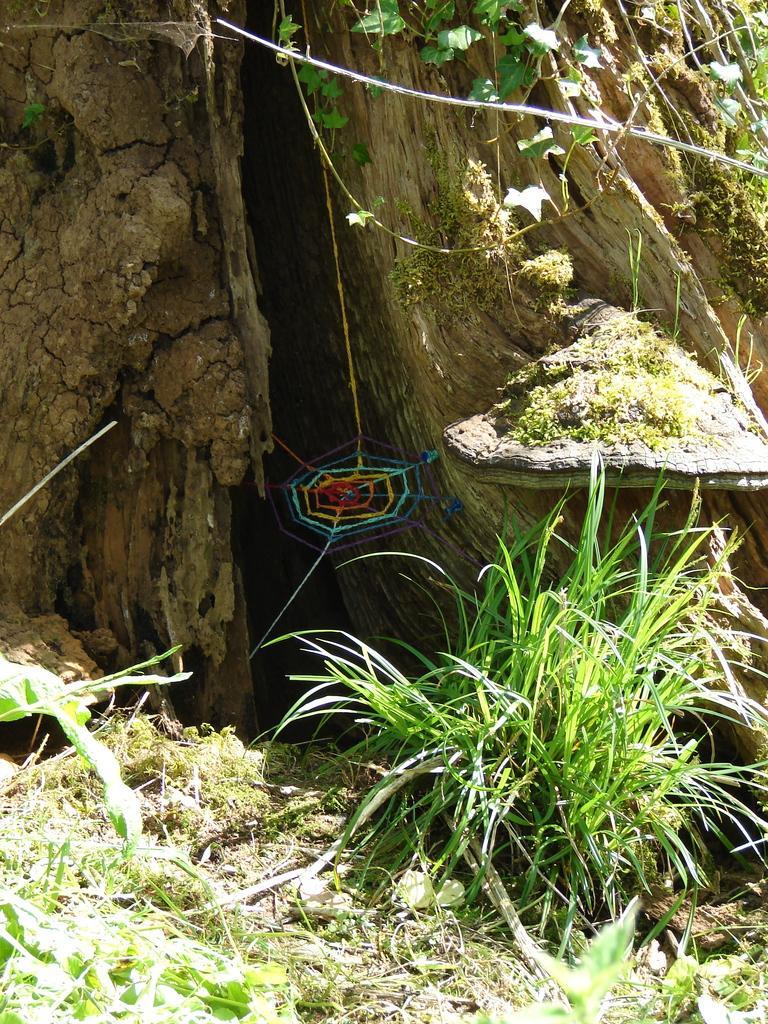In one or two sentences, can you explain what this image depicts? In this image there is grass, plants, spider web, trunk. 